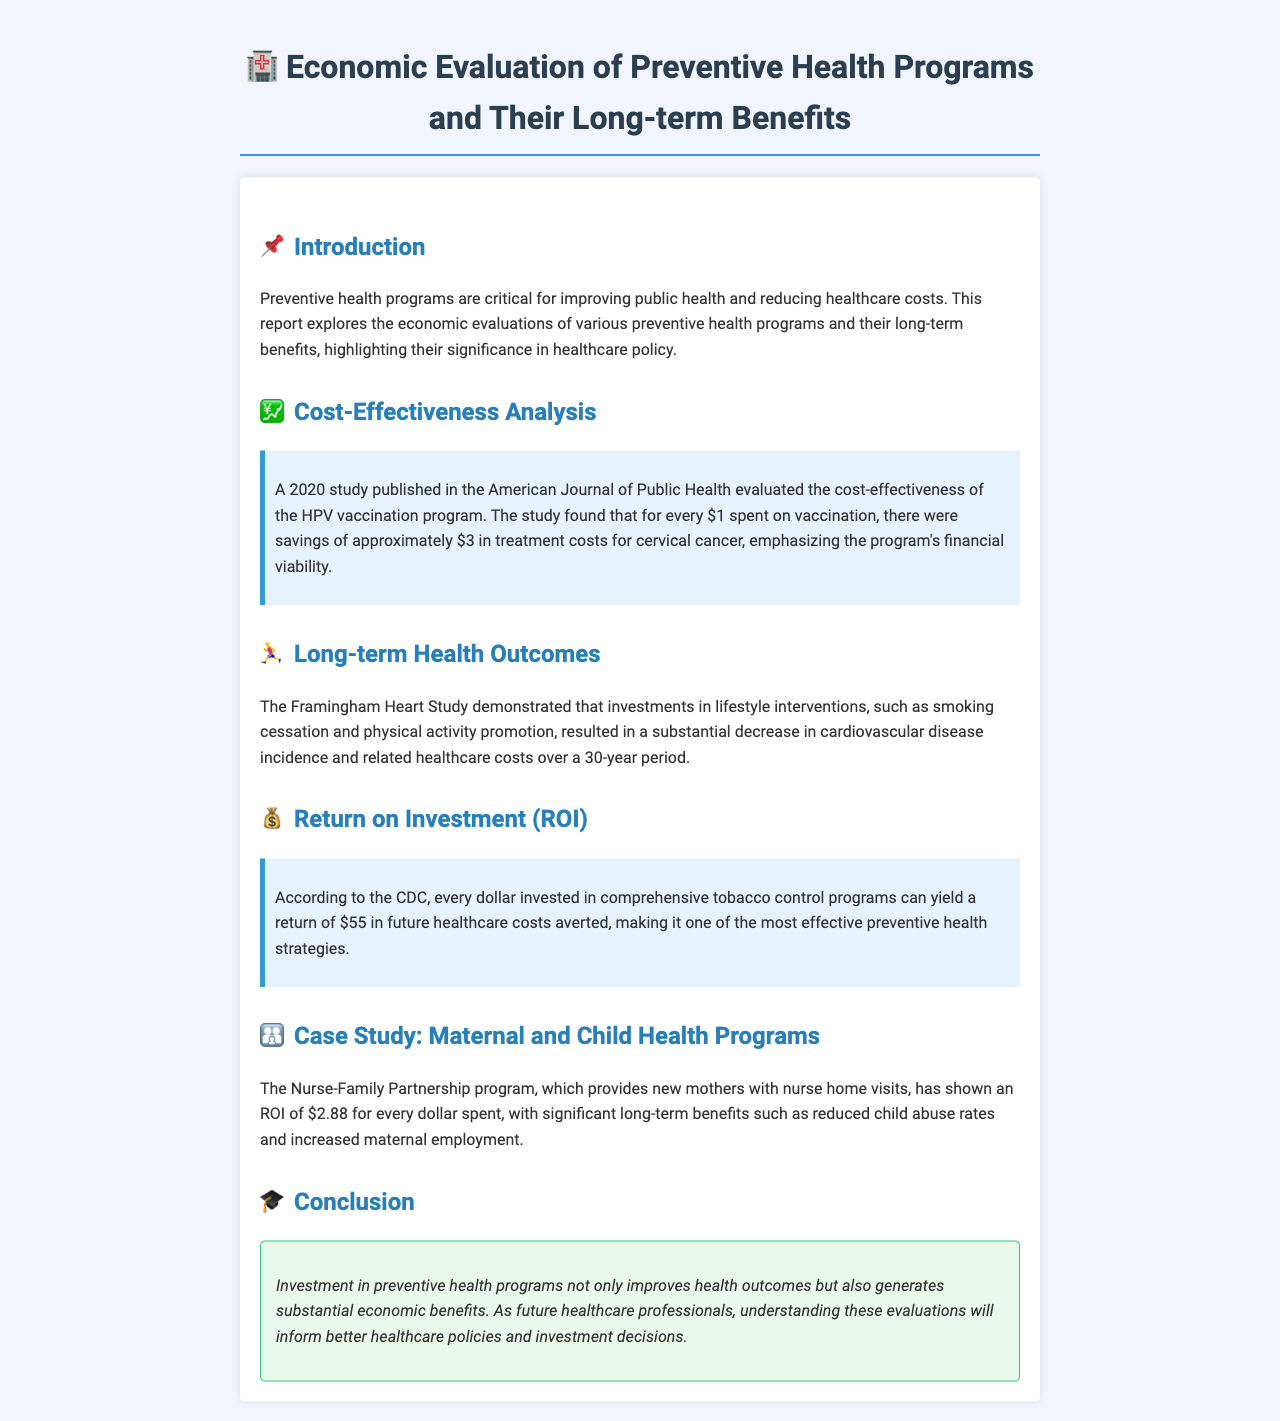What is the main focus of the report? The report focuses on the economic evaluations of various preventive health programs and their long-term benefits.
Answer: Economic evaluations of preventive health programs According to the 2020 study, what is the savings for every dollar spent on HPV vaccination? The study found that for every dollar spent on vaccination, there were savings of approximately three dollars in treatment costs for cervical cancer.
Answer: Three dollars What program is highlighted in the case study related to maternal and child health? The case study highlights the Nurse-Family Partnership program.
Answer: Nurse-Family Partnership program What is the ROI for comprehensive tobacco control programs according to the CDC? The CDC states that every dollar invested in comprehensive tobacco control programs can yield a return of fifty-five dollars in future healthcare costs averted.
Answer: Fifty-five dollars What long-term health intervention is mentioned in the Framingham Heart Study? The Framingham Heart Study mentioned investments in lifestyle interventions, such as smoking cessation and physical activity promotion.
Answer: Smoking cessation and physical activity promotion What significant benefit does the Nurse-Family Partnership program provide besides reduced child abuse rates? The program also results in increased maternal employment.
Answer: Increased maternal employment 